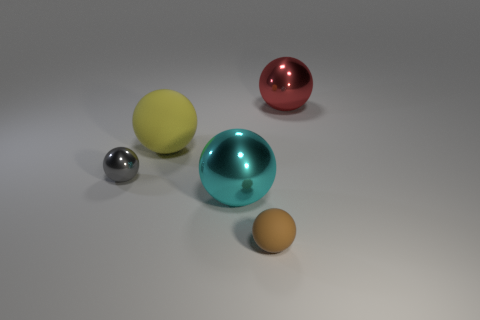Is the size of the object that is in front of the cyan shiny thing the same as the matte ball that is on the left side of the brown thing?
Offer a very short reply. No. What number of brown things are the same size as the gray metal sphere?
Give a very brief answer. 1. Is there a tiny yellow matte cylinder?
Offer a terse response. No. What color is the shiny thing that is behind the matte ball that is left of the big metallic sphere that is left of the red object?
Offer a terse response. Red. Are there the same number of red shiny things in front of the gray shiny object and small blocks?
Provide a succinct answer. Yes. Do the small metal ball and the big shiny ball to the left of the tiny matte sphere have the same color?
Your response must be concise. No. Are there any cyan shiny balls that are behind the tiny thing to the right of the thing left of the big matte thing?
Give a very brief answer. Yes. Is the number of tiny gray things right of the brown sphere less than the number of big objects?
Offer a very short reply. Yes. How many other objects are the same shape as the tiny rubber object?
Give a very brief answer. 4. How many objects are large shiny spheres on the left side of the brown ball or large shiny spheres behind the yellow sphere?
Keep it short and to the point. 2. 